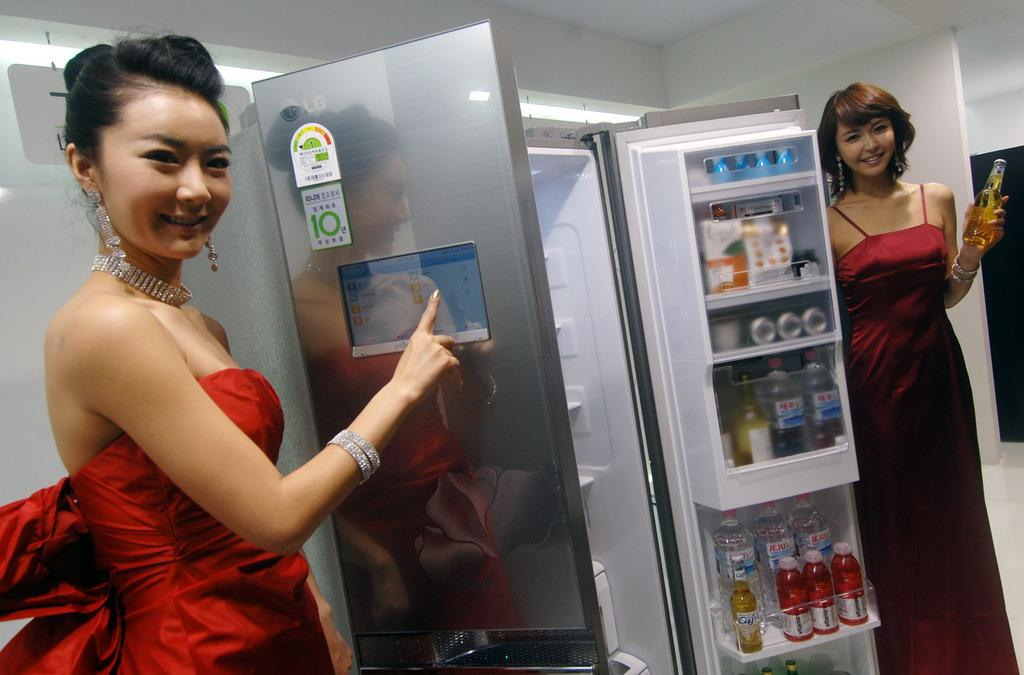<image>
Share a concise interpretation of the image provided. A girl stands near an open fridge that has a white label with the number 10 on the door. 